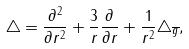Convert formula to latex. <formula><loc_0><loc_0><loc_500><loc_500>\triangle = \frac { \partial ^ { 2 } } { \partial r ^ { 2 } } + \frac { 3 } { r } \frac { \partial } { \partial r } + \frac { 1 } { r ^ { 2 } } \triangle _ { \overline { g } } ,</formula> 